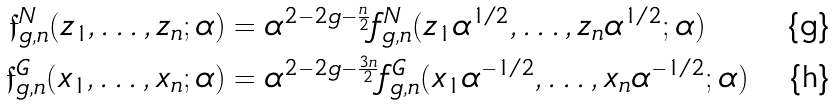<formula> <loc_0><loc_0><loc_500><loc_500>\mathfrak { f } _ { g , n } ^ { N } ( z _ { 1 } , \dots , z _ { n } ; \alpha ) & = \alpha ^ { 2 - 2 g - \frac { n } { 2 } } { f } _ { g , n } ^ { N } ( z _ { 1 } \alpha ^ { 1 / 2 } , \dots , z _ { n } \alpha ^ { 1 / 2 } ; \alpha ) \\ \mathfrak { f } _ { g , n } ^ { G } ( x _ { 1 } , \dots , x _ { n } ; \alpha ) & = \alpha ^ { 2 - 2 g - \frac { 3 n } { 2 } } { f } _ { g , n } ^ { G } ( x _ { 1 } \alpha ^ { - 1 / 2 } , \dots , x _ { n } \alpha ^ { - 1 / 2 } ; \alpha )</formula> 